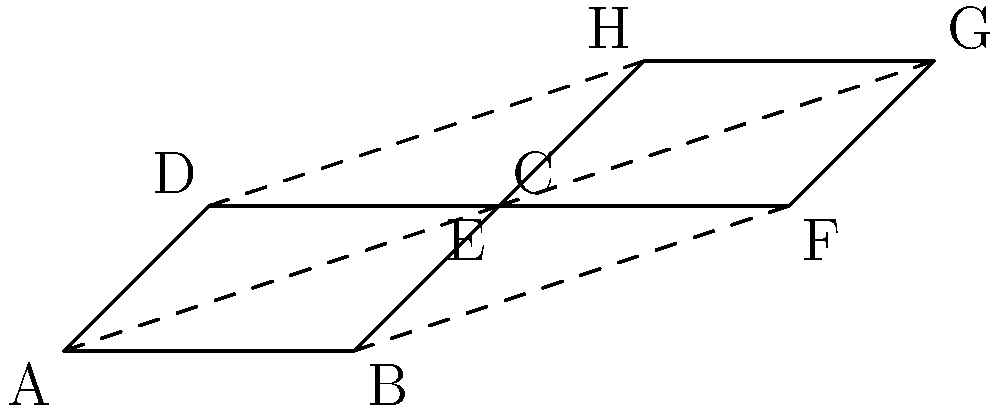In the tessellation pattern shown above, quadrilaterals $ABCD$ and $EFGH$ are congruent. If the area of quadrilateral $ABCD$ is 2 square units and $\overline{AB} = 2$ units, what is the length of $\overline{BC}$? To solve this problem, let's follow these steps:

1) First, recall that congruent shapes have the same area. So, the area of $EFGH$ is also 2 square units.

2) In a quadrilateral, if we know the base and height, we can calculate the area using the formula: $Area = base \times height$

3) We're given that $\overline{AB} = 2$ units. This is the base of the quadrilateral.

4) Using the area formula: $2 = 2 \times height$

5) Solving for height: $height = 1$ unit

6) Now, we can see that $\overline{BC}$ is the hypotenuse of a right triangle formed by the base extension and the height.

7) We can use the Pythagorean theorem to find $\overline{BC}$:

   $BC^2 = 1^2 + 1^2$

8) Simplifying: $BC^2 = 1 + 1 = 2$

9) Taking the square root of both sides: $BC = \sqrt{2}$

Therefore, the length of $\overline{BC}$ is $\sqrt{2}$ units.
Answer: $\sqrt{2}$ units 